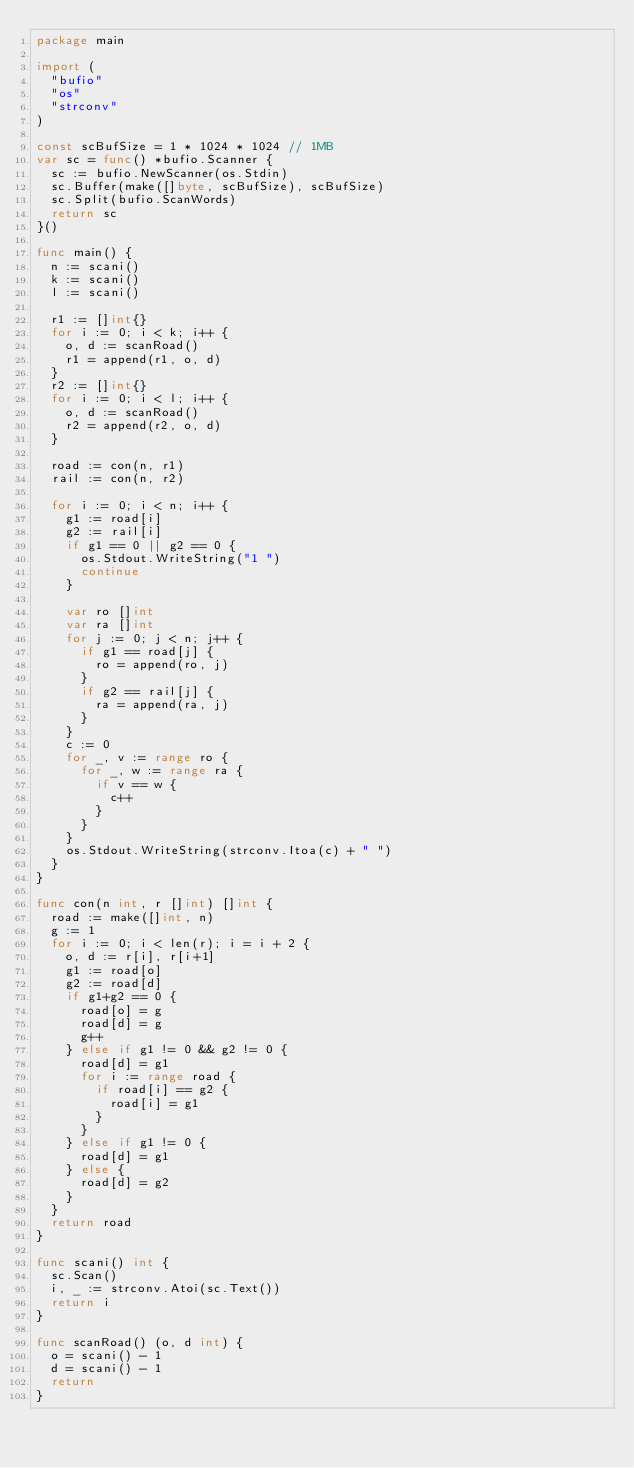<code> <loc_0><loc_0><loc_500><loc_500><_Go_>package main

import (
	"bufio"
	"os"
	"strconv"
)

const scBufSize = 1 * 1024 * 1024 // 1MB
var sc = func() *bufio.Scanner {
	sc := bufio.NewScanner(os.Stdin)
	sc.Buffer(make([]byte, scBufSize), scBufSize)
	sc.Split(bufio.ScanWords)
	return sc
}()

func main() {
	n := scani()
	k := scani()
	l := scani()

	r1 := []int{}
	for i := 0; i < k; i++ {
		o, d := scanRoad()
		r1 = append(r1, o, d)
	}
	r2 := []int{}
	for i := 0; i < l; i++ {
		o, d := scanRoad()
		r2 = append(r2, o, d)
	}

	road := con(n, r1)
	rail := con(n, r2)

	for i := 0; i < n; i++ {
		g1 := road[i]
		g2 := rail[i]
		if g1 == 0 || g2 == 0 {
			os.Stdout.WriteString("1 ")
			continue
		}

		var ro []int
		var ra []int
		for j := 0; j < n; j++ {
			if g1 == road[j] {
				ro = append(ro, j)
			}
			if g2 == rail[j] {
				ra = append(ra, j)
			}
		}
		c := 0
		for _, v := range ro {
			for _, w := range ra {
				if v == w {
					c++
				}
			}
		}
		os.Stdout.WriteString(strconv.Itoa(c) + " ")
	}
}

func con(n int, r []int) []int {
	road := make([]int, n)
	g := 1
	for i := 0; i < len(r); i = i + 2 {
		o, d := r[i], r[i+1]
		g1 := road[o]
		g2 := road[d]
		if g1+g2 == 0 {
			road[o] = g
			road[d] = g
			g++
		} else if g1 != 0 && g2 != 0 {
			road[d] = g1
			for i := range road {
				if road[i] == g2 {
					road[i] = g1
				}
			}
		} else if g1 != 0 {
			road[d] = g1
		} else {
			road[d] = g2
		}
	}
	return road
}

func scani() int {
	sc.Scan()
	i, _ := strconv.Atoi(sc.Text())
	return i
}

func scanRoad() (o, d int) {
	o = scani() - 1
	d = scani() - 1
	return
}
</code> 